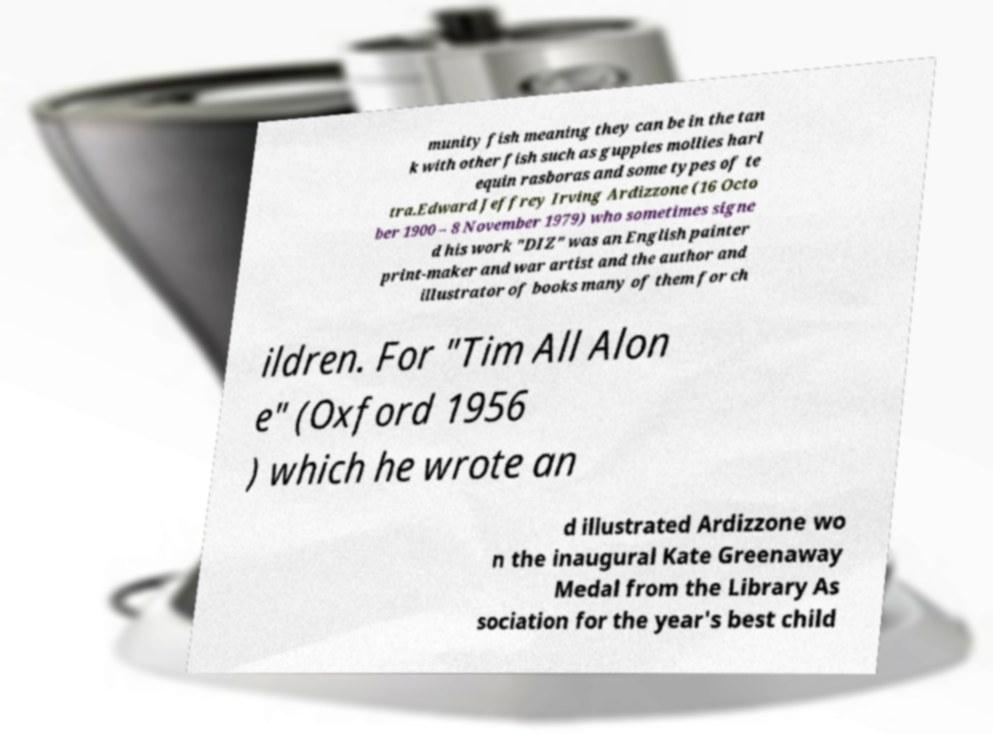Please read and relay the text visible in this image. What does it say? munity fish meaning they can be in the tan k with other fish such as guppies mollies harl equin rasboras and some types of te tra.Edward Jeffrey Irving Ardizzone (16 Octo ber 1900 – 8 November 1979) who sometimes signe d his work "DIZ" was an English painter print-maker and war artist and the author and illustrator of books many of them for ch ildren. For "Tim All Alon e" (Oxford 1956 ) which he wrote an d illustrated Ardizzone wo n the inaugural Kate Greenaway Medal from the Library As sociation for the year's best child 